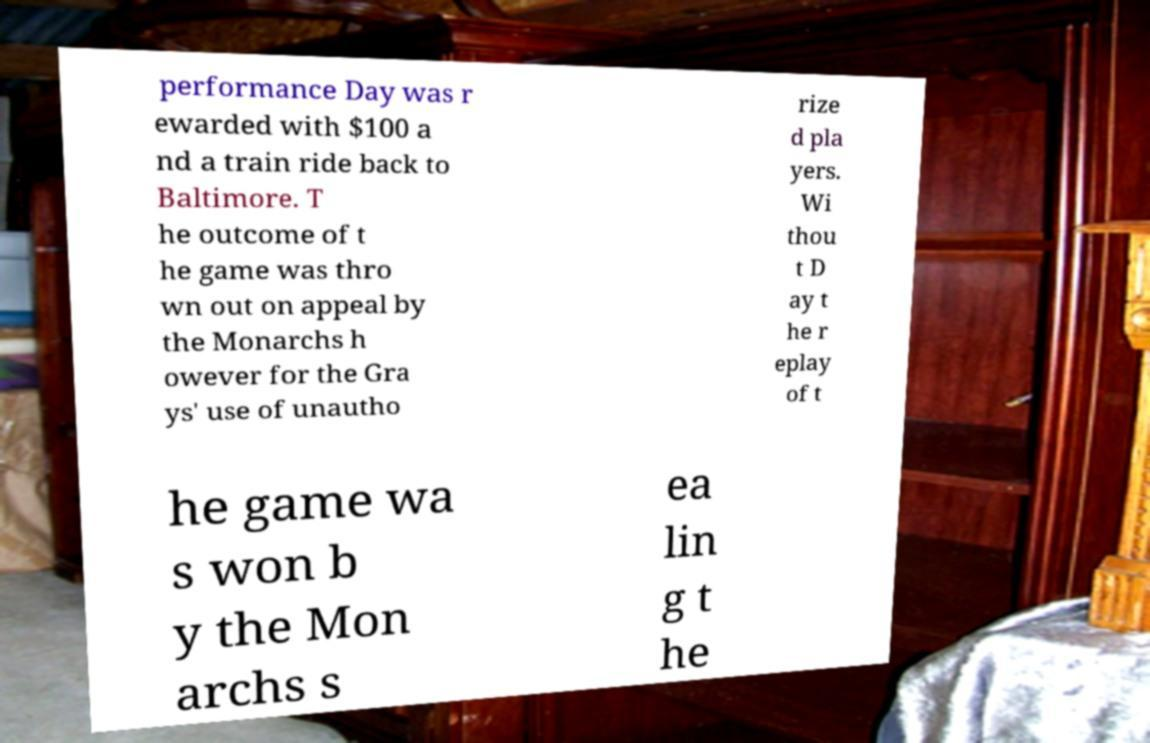Can you read and provide the text displayed in the image?This photo seems to have some interesting text. Can you extract and type it out for me? performance Day was r ewarded with $100 a nd a train ride back to Baltimore. T he outcome of t he game was thro wn out on appeal by the Monarchs h owever for the Gra ys' use of unautho rize d pla yers. Wi thou t D ay t he r eplay of t he game wa s won b y the Mon archs s ea lin g t he 